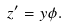Convert formula to latex. <formula><loc_0><loc_0><loc_500><loc_500>z ^ { \prime } = y \phi .</formula> 